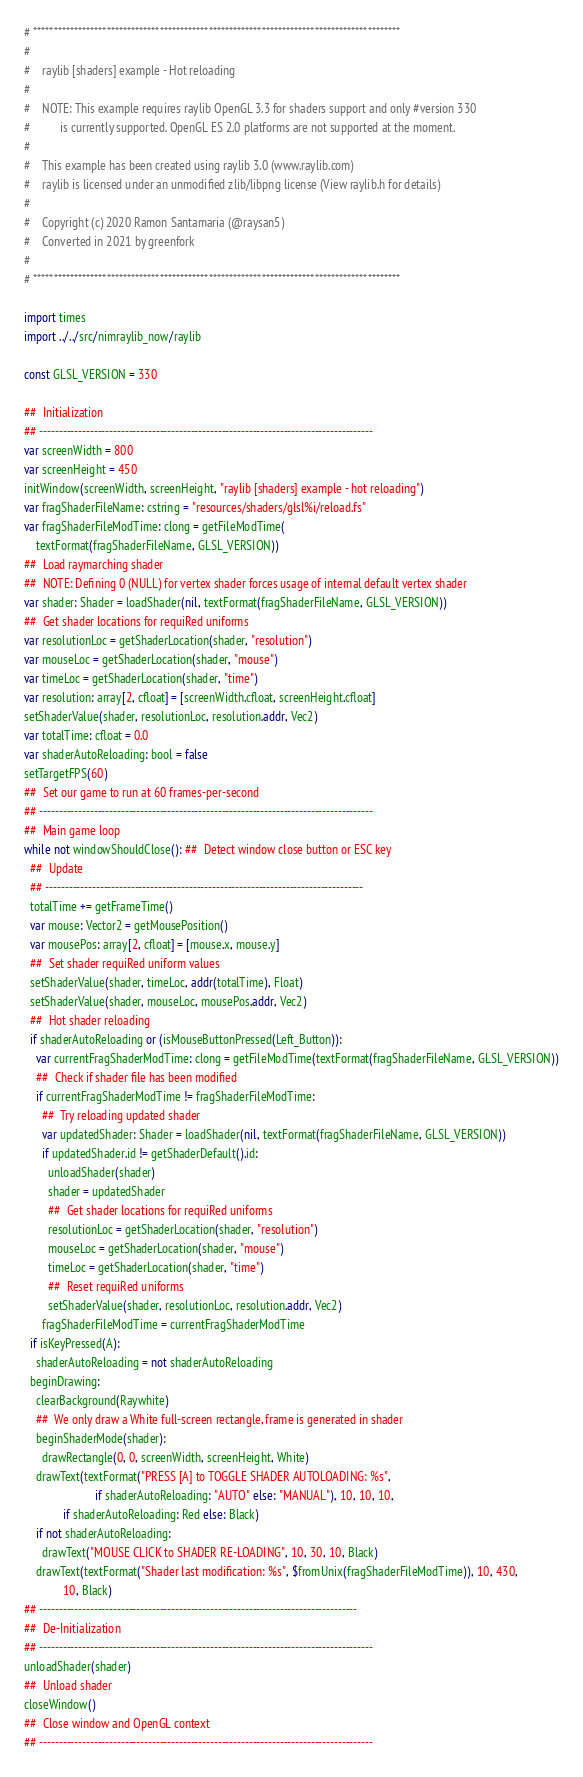<code> <loc_0><loc_0><loc_500><loc_500><_Nim_># ******************************************************************************************
#
#    raylib [shaders] example - Hot reloading
#
#    NOTE: This example requires raylib OpenGL 3.3 for shaders support and only #version 330
#          is currently supported. OpenGL ES 2.0 platforms are not supported at the moment.
#
#    This example has been created using raylib 3.0 (www.raylib.com)
#    raylib is licensed under an unmodified zlib/libpng license (View raylib.h for details)
#
#    Copyright (c) 2020 Ramon Santamaria (@raysan5)
#    Converted in 2021 by greenfork
#
# ******************************************************************************************

import times
import ../../src/nimraylib_now/raylib

const GLSL_VERSION = 330

##  Initialization
## --------------------------------------------------------------------------------------
var screenWidth = 800
var screenHeight = 450
initWindow(screenWidth, screenHeight, "raylib [shaders] example - hot reloading")
var fragShaderFileName: cstring = "resources/shaders/glsl%i/reload.fs"
var fragShaderFileModTime: clong = getFileModTime(
    textFormat(fragShaderFileName, GLSL_VERSION))
##  Load raymarching shader
##  NOTE: Defining 0 (NULL) for vertex shader forces usage of internal default vertex shader
var shader: Shader = loadShader(nil, textFormat(fragShaderFileName, GLSL_VERSION))
##  Get shader locations for requiRed uniforms
var resolutionLoc = getShaderLocation(shader, "resolution")
var mouseLoc = getShaderLocation(shader, "mouse")
var timeLoc = getShaderLocation(shader, "time")
var resolution: array[2, cfloat] = [screenWidth.cfloat, screenHeight.cfloat]
setShaderValue(shader, resolutionLoc, resolution.addr, Vec2)
var totalTime: cfloat = 0.0
var shaderAutoReloading: bool = false
setTargetFPS(60)
##  Set our game to run at 60 frames-per-second
## --------------------------------------------------------------------------------------
##  Main game loop
while not windowShouldClose(): ##  Detect window close button or ESC key
  ##  Update
  ## ----------------------------------------------------------------------------------
  totalTime += getFrameTime()
  var mouse: Vector2 = getMousePosition()
  var mousePos: array[2, cfloat] = [mouse.x, mouse.y]
  ##  Set shader requiRed uniform values
  setShaderValue(shader, timeLoc, addr(totalTime), Float)
  setShaderValue(shader, mouseLoc, mousePos.addr, Vec2)
  ##  Hot shader reloading
  if shaderAutoReloading or (isMouseButtonPressed(Left_Button)):
    var currentFragShaderModTime: clong = getFileModTime(textFormat(fragShaderFileName, GLSL_VERSION))
    ##  Check if shader file has been modified
    if currentFragShaderModTime != fragShaderFileModTime:
      ##  Try reloading updated shader
      var updatedShader: Shader = loadShader(nil, textFormat(fragShaderFileName, GLSL_VERSION))
      if updatedShader.id != getShaderDefault().id:
        unloadShader(shader)
        shader = updatedShader
        ##  Get shader locations for requiRed uniforms
        resolutionLoc = getShaderLocation(shader, "resolution")
        mouseLoc = getShaderLocation(shader, "mouse")
        timeLoc = getShaderLocation(shader, "time")
        ##  Reset requiRed uniforms
        setShaderValue(shader, resolutionLoc, resolution.addr, Vec2)
      fragShaderFileModTime = currentFragShaderModTime
  if isKeyPressed(A):
    shaderAutoReloading = not shaderAutoReloading
  beginDrawing:
    clearBackground(Raywhite)
    ##  We only draw a White full-screen rectangle, frame is generated in shader
    beginShaderMode(shader):
      drawRectangle(0, 0, screenWidth, screenHeight, White)
    drawText(textFormat("PRESS [A] to TOGGLE SHADER AUTOLOADING: %s",
                        if shaderAutoReloading: "AUTO" else: "MANUAL"), 10, 10, 10,
             if shaderAutoReloading: Red else: Black)
    if not shaderAutoReloading:
      drawText("MOUSE CLICK to SHADER RE-LOADING", 10, 30, 10, Black)
    drawText(textFormat("Shader last modification: %s", $fromUnix(fragShaderFileModTime)), 10, 430,
             10, Black)
## ----------------------------------------------------------------------------------
##  De-Initialization
## --------------------------------------------------------------------------------------
unloadShader(shader)
##  Unload shader
closeWindow()
##  Close window and OpenGL context
## --------------------------------------------------------------------------------------
</code> 